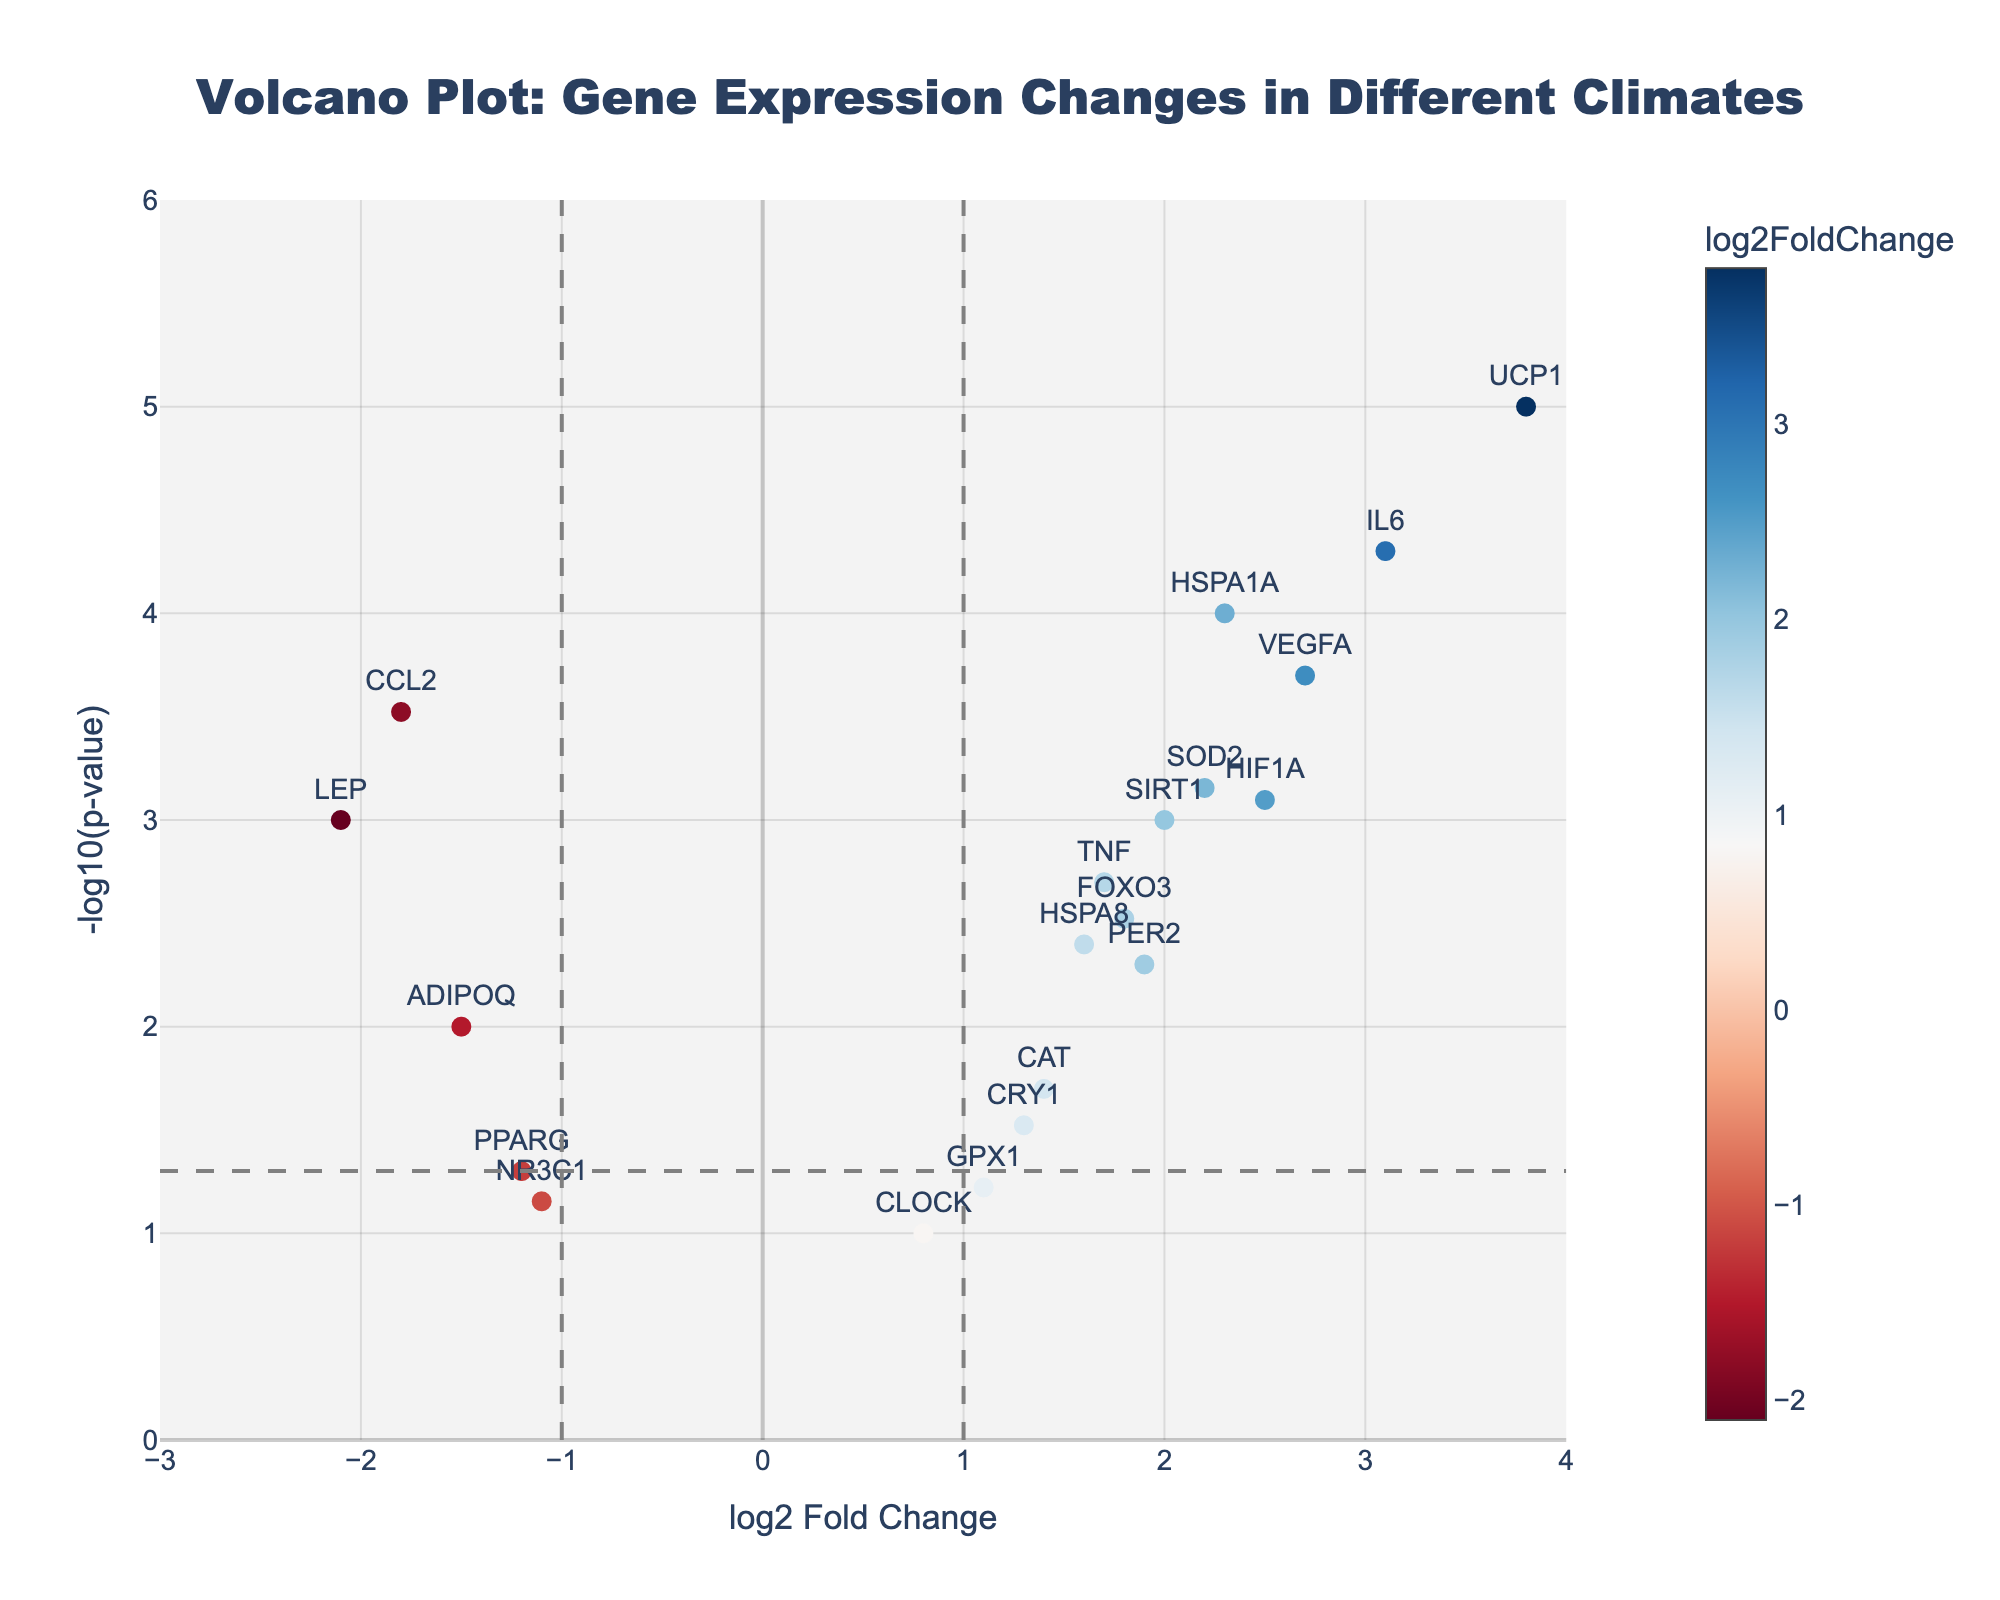How many genes have a log2 Fold Change greater than 2? To find the number of genes with a log2 Fold Change greater than 2, we look along the x-axis for values above 2 and count the data points. From the figure, the genes with log2 Fold Change > 2 are `HSPA1A`, `IL6`, `UCP1`, `VEGFA`, and `HIF1A`.
Answer: 5 What is the p-value threshold indicated in the plot? The p-value threshold is marked with a horizontal dashed line. To find this value, we convert the y-axis reading at this line (-log10(p-value)), which is observed to be at approximately 1.3. Solving -log10(p-value) = 1.3 gives p-value ≈ 0.05.
Answer: 0.05 Which gene has the highest -log10(p-value)? The gene with the highest -log10(p-value) is the point farthest up the y-axis. From the figure, this is `UCP1`.
Answer: UCP1 How many genes are considered significantly differentially expressed (log2 FC > 1 or < -1 and p < 0.05)? Significant genes are those outside the vertical lines (log2 FC = ±1) and above the horizontal line (-log10(p-value) ≈ 1.3). These include `HSPA1A`, `CCL2`, `IL6`, `UCP1`, `VEGFA`, `LEP`, and `HIF1A`. Count these genes.
Answer: 7 Which gene has the least significant p-value (highest p-value less significant)? The least significant p-value corresponds to the lowest position on the y-axis. From the figure, this is `CLOCK`, indicated by a point around -log10(p-value) closer to the lower boundary.
Answer: CLOCK What can you say about the gene `LEP` based on its position in the plot? To analyze `LEP`, observe its coordinates. Its log2 Fold Change is negative (to the left of zero), and its -log10(p-value) is greater than the threshold indicating significance. Thus, `LEP` is significantly downregulated.
Answer: Significantly downregulated Compare the expression changes and significance levels between `SIRT1` and `HSPA1A`. Which gene has a higher log2 Fold Change and which has a more significant p-value? For `SIRT1` and `HSPA1A`, compare their x and y coordinates. `SIRT1` (log2 FC = 2.0, -log10(p-value) = 3.0) has a lower log2 Fold Change compared to HSPA1A (log2 FC = 2.3, -log10(p-value) = 4.0), and a less significant p-value.
Answer: HSPA1A, HSPA1A Which genes have log2 Fold Changes between -1 and 1, and are they significant? Observe the points between the vertical lines (log2 FC = ±1). These include `PER2`, `CRY1`, `HSPA8`, `CAT`, and `GPX1`. None of these points crosses the horizontal dashed line, so they are not significant.
Answer: PER2, CRY1, HSPA8, CAT, GPX1; Not significant Identify the distribution of log2 Fold Change values. Is there a trend or skewness in the data? To analyze the distribution, observe the spread of points along the x-axis. Most points are positive, suggesting increased expression, with fewer points on the negative side. This indicates a right-skewed distribution, suggesting more genes are upregulated.
Answer: Right-skewed, more upregulated Which gene has a log2 Fold Change closest to zero, and is it significant? Identify the gene nearest the x-axis zero line. `CLOCK` has a log2 Fold Change close to zero (0.8) and lies below the significance threshold, indicating it is not significant.
Answer: CLOCK, Not significant 